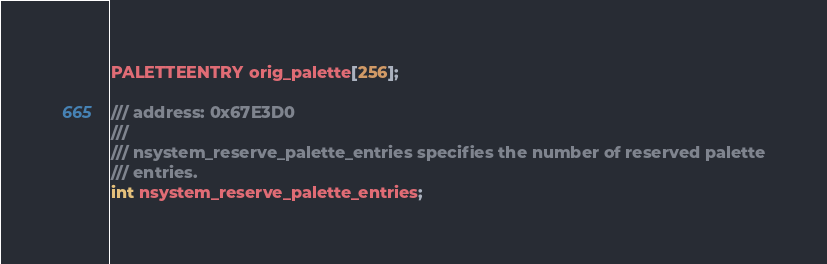Convert code to text. <code><loc_0><loc_0><loc_500><loc_500><_C_>PALETTEENTRY orig_palette[256];

/// address: 0x67E3D0
///
/// nsystem_reserve_palette_entries specifies the number of reserved palette
/// entries.
int nsystem_reserve_palette_entries;
</code> 